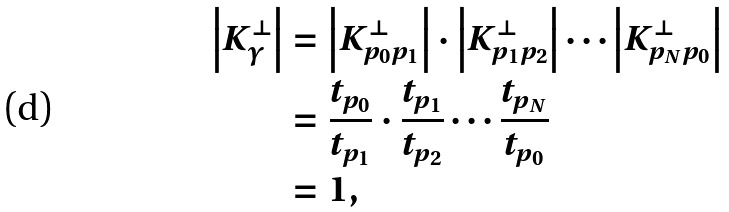<formula> <loc_0><loc_0><loc_500><loc_500>\left | K _ { \gamma } ^ { \perp } \right | & = \left | K ^ { \perp } _ { p _ { 0 } p _ { 1 } } \right | \cdot \left | K ^ { \perp } _ { p _ { 1 } p _ { 2 } } \right | \cdots \left | K ^ { \perp } _ { p _ { N } p _ { 0 } } \right | \\ & = \frac { t _ { p _ { 0 } } } { t _ { p _ { 1 } } } \cdot \frac { t _ { p _ { 1 } } } { t _ { p _ { 2 } } } \cdots \frac { t _ { p _ { N } } } { t _ { p _ { 0 } } } \\ & = 1 ,</formula> 